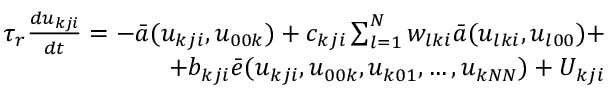<formula> <loc_0><loc_0><loc_500><loc_500>\begin{array} { r } { \tau _ { r } \frac { d u _ { k j i } } { d t } = - \bar { a } ( u _ { k j i } , u _ { 0 0 k } ) + c _ { k j i } \sum _ { l = 1 } ^ { N } w _ { l k i } \bar { a } ( u _ { l k i } , u _ { l 0 0 } ) + } \\ { + b _ { k j i } \bar { e } ( u _ { k j i } , u _ { 0 0 k } , u _ { k 0 1 } , \dots , u _ { k N N } ) + U _ { k j i } } \end{array}</formula> 